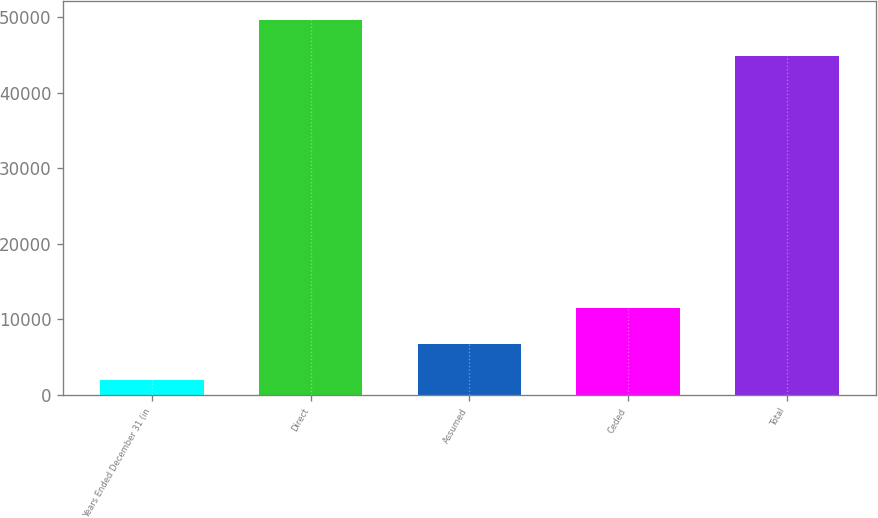Convert chart to OTSL. <chart><loc_0><loc_0><loc_500><loc_500><bar_chart><fcel>Years Ended December 31 (in<fcel>Direct<fcel>Assumed<fcel>Ceded<fcel>Total<nl><fcel>2006<fcel>49626.3<fcel>6766.3<fcel>11526.6<fcel>44866<nl></chart> 